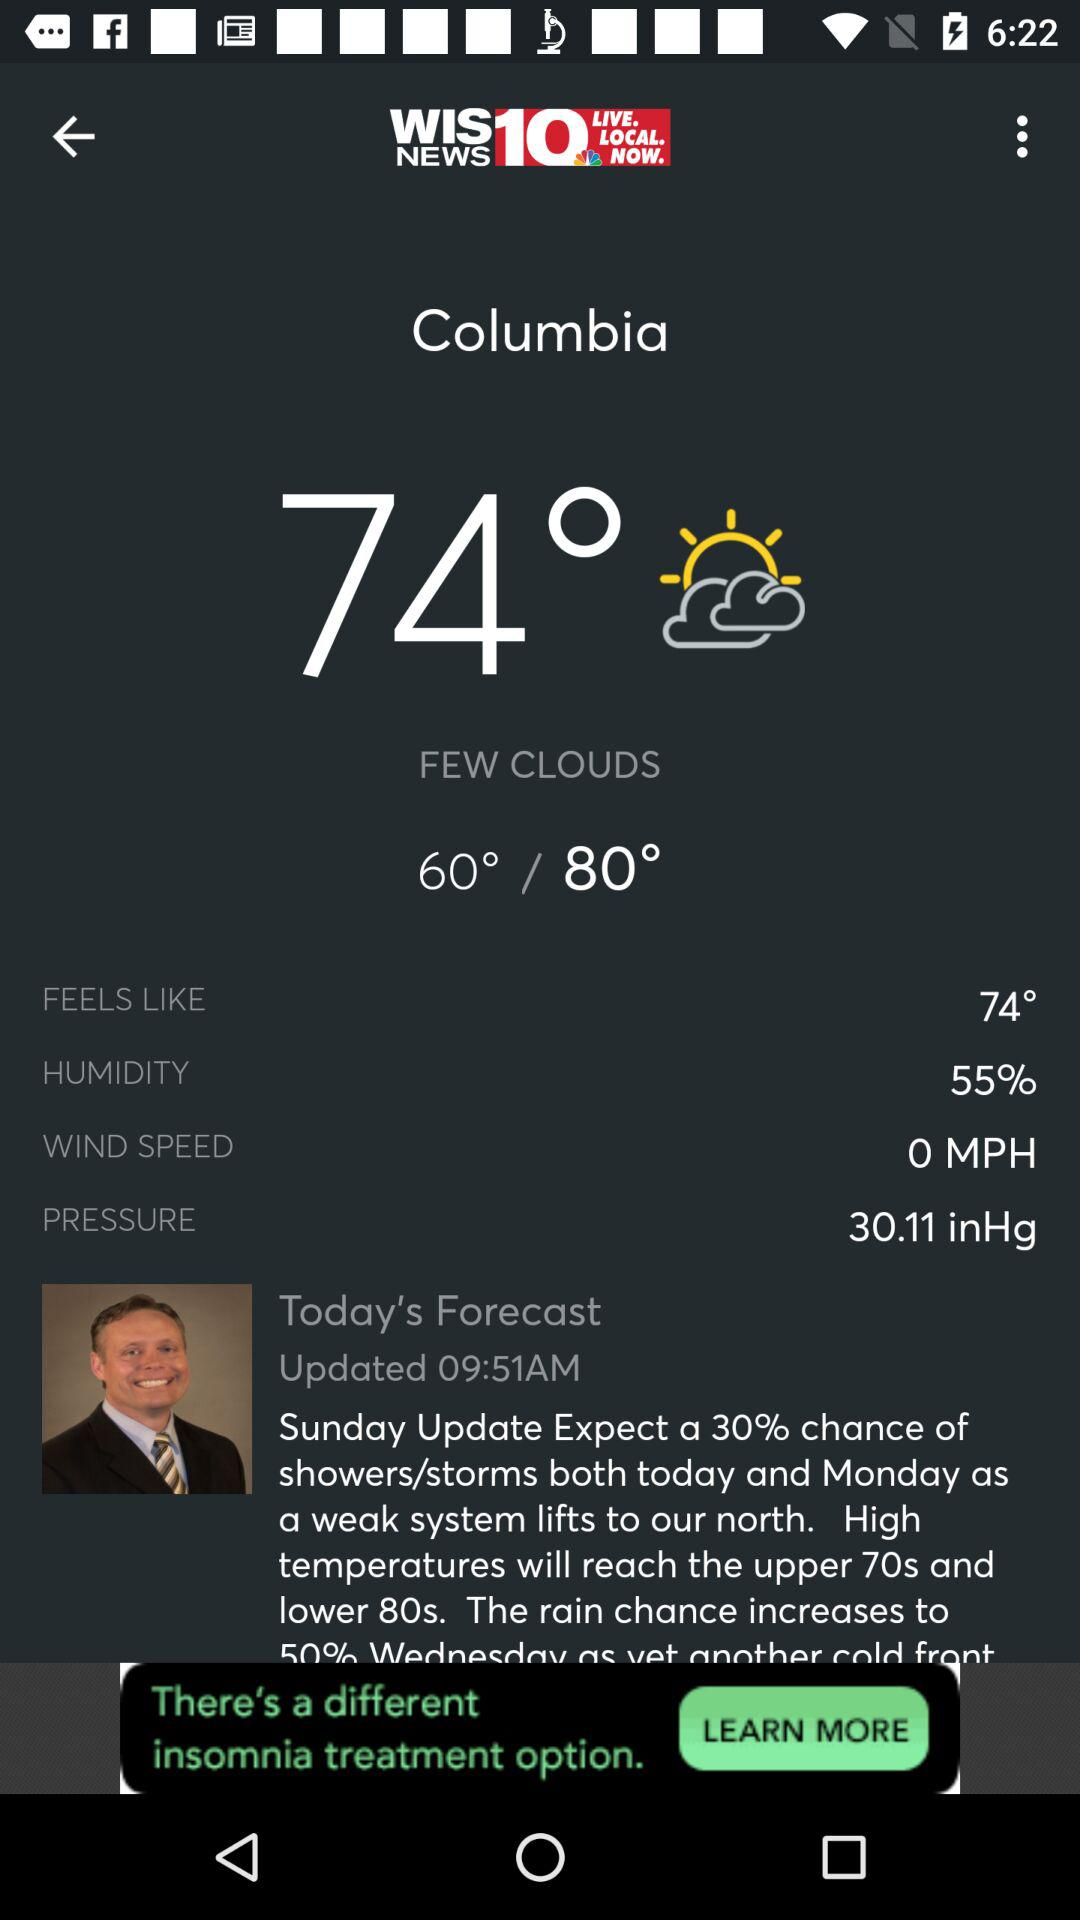What is the difference between the high and low temperatures?
Answer the question using a single word or phrase. 20° 